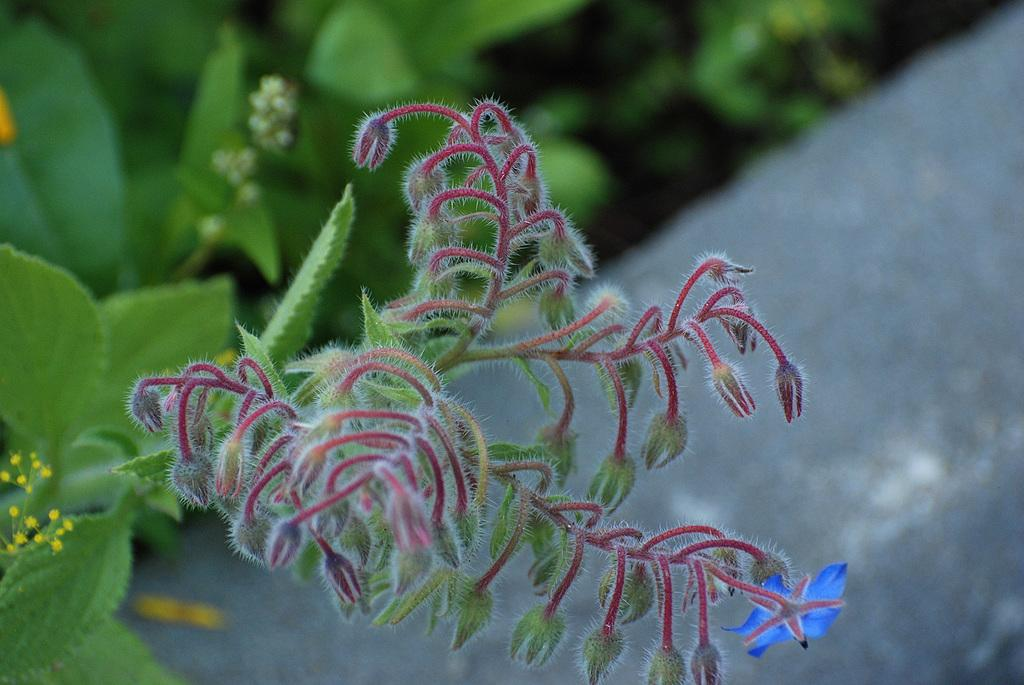What type of living organisms can be seen in the image? There are flowers in the image. Where are the flowers located? The flowers are present on plants. What committee is responsible for the growth of the flowers in the image? There is no committee mentioned or implied in the image, as it only shows flowers on plants. 